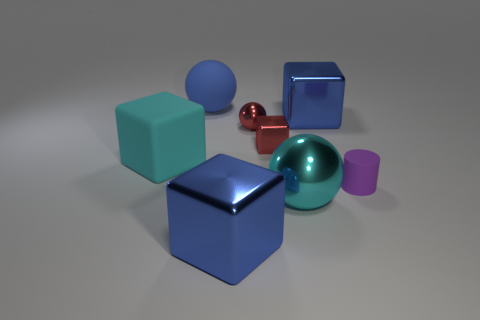Can you tell the approximate sizes of the objects relative to each other? The two large cubes are the biggest objects in the scene, followed by the large sphere. The small red sphere is the smallest object, and the magenta cylinder and cube are of medium size, situated between the large objects and the small sphere. 